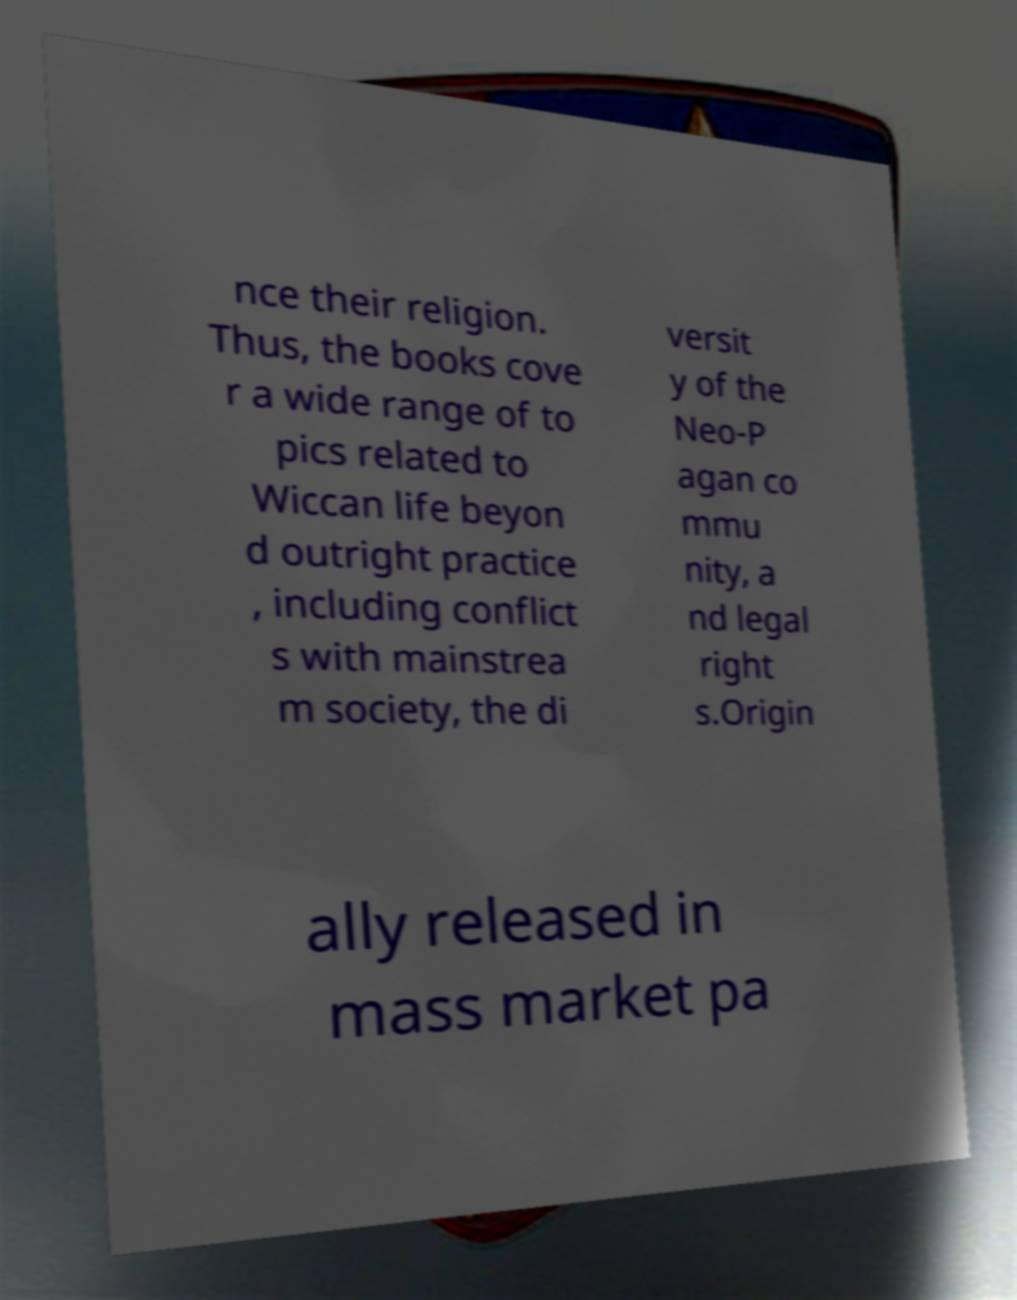Can you read and provide the text displayed in the image?This photo seems to have some interesting text. Can you extract and type it out for me? nce their religion. Thus, the books cove r a wide range of to pics related to Wiccan life beyon d outright practice , including conflict s with mainstrea m society, the di versit y of the Neo-P agan co mmu nity, a nd legal right s.Origin ally released in mass market pa 